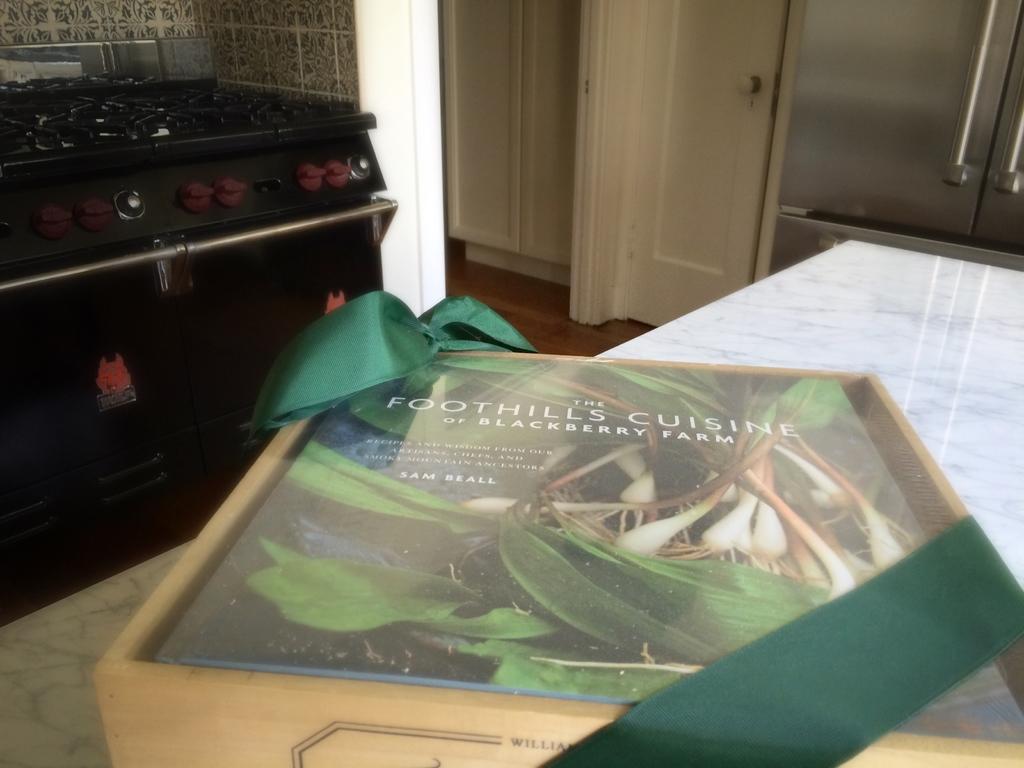What is the name of the book?
Offer a terse response. Foothills cuisine. What is the name of the book?
Provide a short and direct response. The foothills cuisine of blackberry farm. 